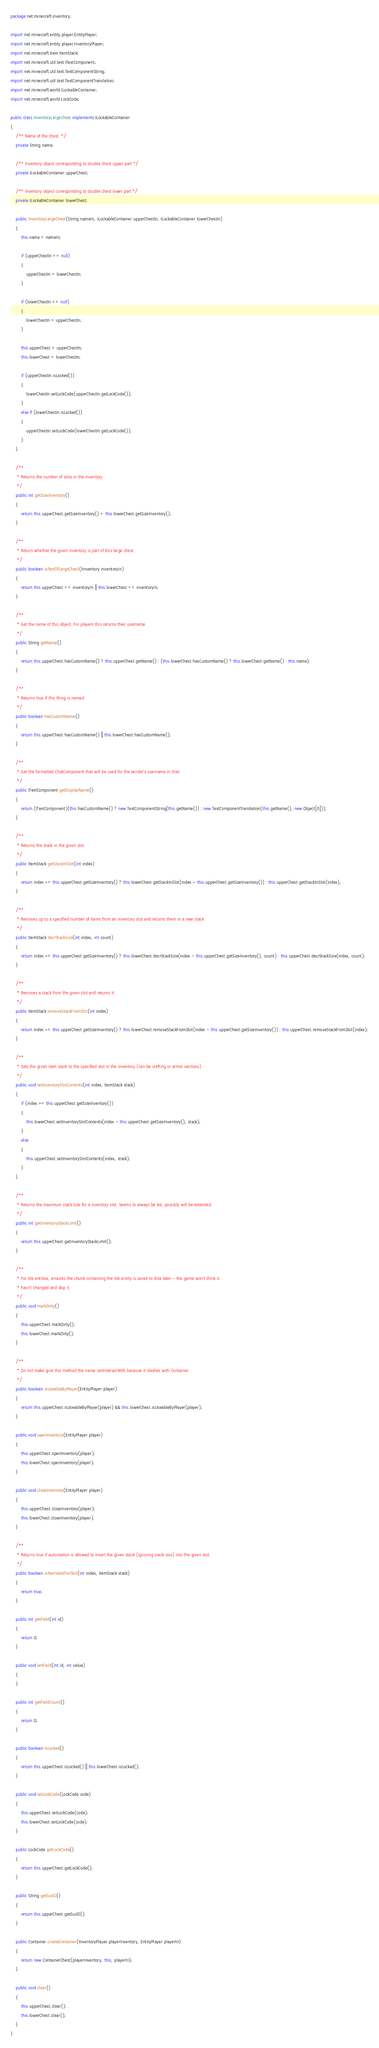Convert code to text. <code><loc_0><loc_0><loc_500><loc_500><_Java_>package net.minecraft.inventory;

import net.minecraft.entity.player.EntityPlayer;
import net.minecraft.entity.player.InventoryPlayer;
import net.minecraft.item.ItemStack;
import net.minecraft.util.text.ITextComponent;
import net.minecraft.util.text.TextComponentString;
import net.minecraft.util.text.TextComponentTranslation;
import net.minecraft.world.ILockableContainer;
import net.minecraft.world.LockCode;

public class InventoryLargeChest implements ILockableContainer
{
    /** Name of the chest. */
    private String name;

    /** Inventory object corresponding to double chest upper part */
    private ILockableContainer upperChest;

    /** Inventory object corresponding to double chest lower part */
    private ILockableContainer lowerChest;

    public InventoryLargeChest(String nameIn, ILockableContainer upperChestIn, ILockableContainer lowerChestIn)
    {
        this.name = nameIn;

        if (upperChestIn == null)
        {
            upperChestIn = lowerChestIn;
        }

        if (lowerChestIn == null)
        {
            lowerChestIn = upperChestIn;
        }

        this.upperChest = upperChestIn;
        this.lowerChest = lowerChestIn;

        if (upperChestIn.isLocked())
        {
            lowerChestIn.setLockCode(upperChestIn.getLockCode());
        }
        else if (lowerChestIn.isLocked())
        {
            upperChestIn.setLockCode(lowerChestIn.getLockCode());
        }
    }

    /**
     * Returns the number of slots in the inventory.
     */
    public int getSizeInventory()
    {
        return this.upperChest.getSizeInventory() + this.lowerChest.getSizeInventory();
    }

    /**
     * Return whether the given inventory is part of this large chest.
     */
    public boolean isPartOfLargeChest(IInventory inventoryIn)
    {
        return this.upperChest == inventoryIn || this.lowerChest == inventoryIn;
    }

    /**
     * Get the name of this object. For players this returns their username
     */
    public String getName()
    {
        return this.upperChest.hasCustomName() ? this.upperChest.getName() : (this.lowerChest.hasCustomName() ? this.lowerChest.getName() : this.name);
    }

    /**
     * Returns true if this thing is named
     */
    public boolean hasCustomName()
    {
        return this.upperChest.hasCustomName() || this.lowerChest.hasCustomName();
    }

    /**
     * Get the formatted ChatComponent that will be used for the sender's username in chat
     */
    public ITextComponent getDisplayName()
    {
        return (ITextComponent)(this.hasCustomName() ? new TextComponentString(this.getName()) : new TextComponentTranslation(this.getName(), new Object[0]));
    }

    /**
     * Returns the stack in the given slot.
     */
    public ItemStack getStackInSlot(int index)
    {
        return index >= this.upperChest.getSizeInventory() ? this.lowerChest.getStackInSlot(index - this.upperChest.getSizeInventory()) : this.upperChest.getStackInSlot(index);
    }

    /**
     * Removes up to a specified number of items from an inventory slot and returns them in a new stack.
     */
    public ItemStack decrStackSize(int index, int count)
    {
        return index >= this.upperChest.getSizeInventory() ? this.lowerChest.decrStackSize(index - this.upperChest.getSizeInventory(), count) : this.upperChest.decrStackSize(index, count);
    }

    /**
     * Removes a stack from the given slot and returns it.
     */
    public ItemStack removeStackFromSlot(int index)
    {
        return index >= this.upperChest.getSizeInventory() ? this.lowerChest.removeStackFromSlot(index - this.upperChest.getSizeInventory()) : this.upperChest.removeStackFromSlot(index);
    }

    /**
     * Sets the given item stack to the specified slot in the inventory (can be crafting or armor sections).
     */
    public void setInventorySlotContents(int index, ItemStack stack)
    {
        if (index >= this.upperChest.getSizeInventory())
        {
            this.lowerChest.setInventorySlotContents(index - this.upperChest.getSizeInventory(), stack);
        }
        else
        {
            this.upperChest.setInventorySlotContents(index, stack);
        }
    }

    /**
     * Returns the maximum stack size for a inventory slot. Seems to always be 64, possibly will be extended.
     */
    public int getInventoryStackLimit()
    {
        return this.upperChest.getInventoryStackLimit();
    }

    /**
     * For tile entities, ensures the chunk containing the tile entity is saved to disk later - the game won't think it
     * hasn't changed and skip it.
     */
    public void markDirty()
    {
        this.upperChest.markDirty();
        this.lowerChest.markDirty();
    }

    /**
     * Do not make give this method the name canInteractWith because it clashes with Container
     */
    public boolean isUseableByPlayer(EntityPlayer player)
    {
        return this.upperChest.isUseableByPlayer(player) && this.lowerChest.isUseableByPlayer(player);
    }

    public void openInventory(EntityPlayer player)
    {
        this.upperChest.openInventory(player);
        this.lowerChest.openInventory(player);
    }

    public void closeInventory(EntityPlayer player)
    {
        this.upperChest.closeInventory(player);
        this.lowerChest.closeInventory(player);
    }

    /**
     * Returns true if automation is allowed to insert the given stack (ignoring stack size) into the given slot.
     */
    public boolean isItemValidForSlot(int index, ItemStack stack)
    {
        return true;
    }

    public int getField(int id)
    {
        return 0;
    }

    public void setField(int id, int value)
    {
    }

    public int getFieldCount()
    {
        return 0;
    }

    public boolean isLocked()
    {
        return this.upperChest.isLocked() || this.lowerChest.isLocked();
    }

    public void setLockCode(LockCode code)
    {
        this.upperChest.setLockCode(code);
        this.lowerChest.setLockCode(code);
    }

    public LockCode getLockCode()
    {
        return this.upperChest.getLockCode();
    }

    public String getGuiID()
    {
        return this.upperChest.getGuiID();
    }

    public Container createContainer(InventoryPlayer playerInventory, EntityPlayer playerIn)
    {
        return new ContainerChest(playerInventory, this, playerIn);
    }

    public void clear()
    {
        this.upperChest.clear();
        this.lowerChest.clear();
    }
}
</code> 